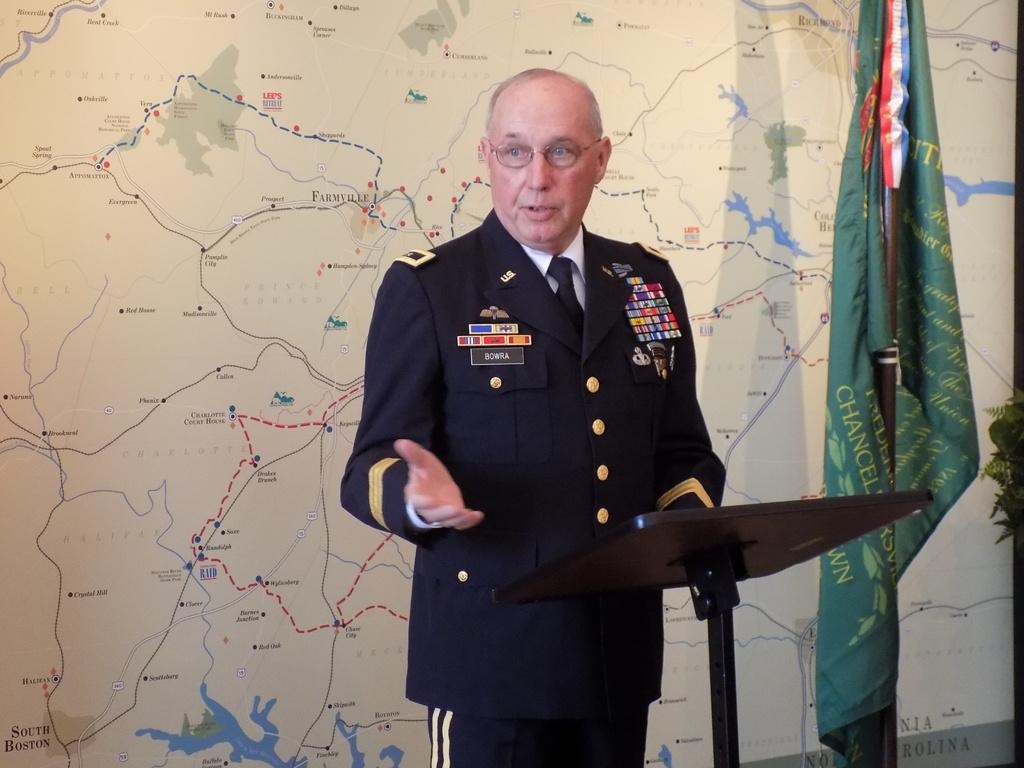What is the person in the image doing? The person is standing at the lectern in the image. What can be seen in the background of the image? There is a map and a flag in the background of the image. What type of yoke is being used by the person in the image? There is no yoke present in the image; the person is standing at a lectern. 